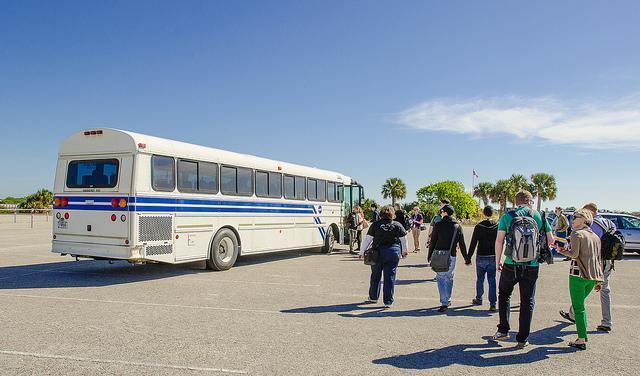How many stories is this bus?
Give a very brief answer. 1. How many people can you see?
Give a very brief answer. 4. How many birds are in a row?
Give a very brief answer. 0. 